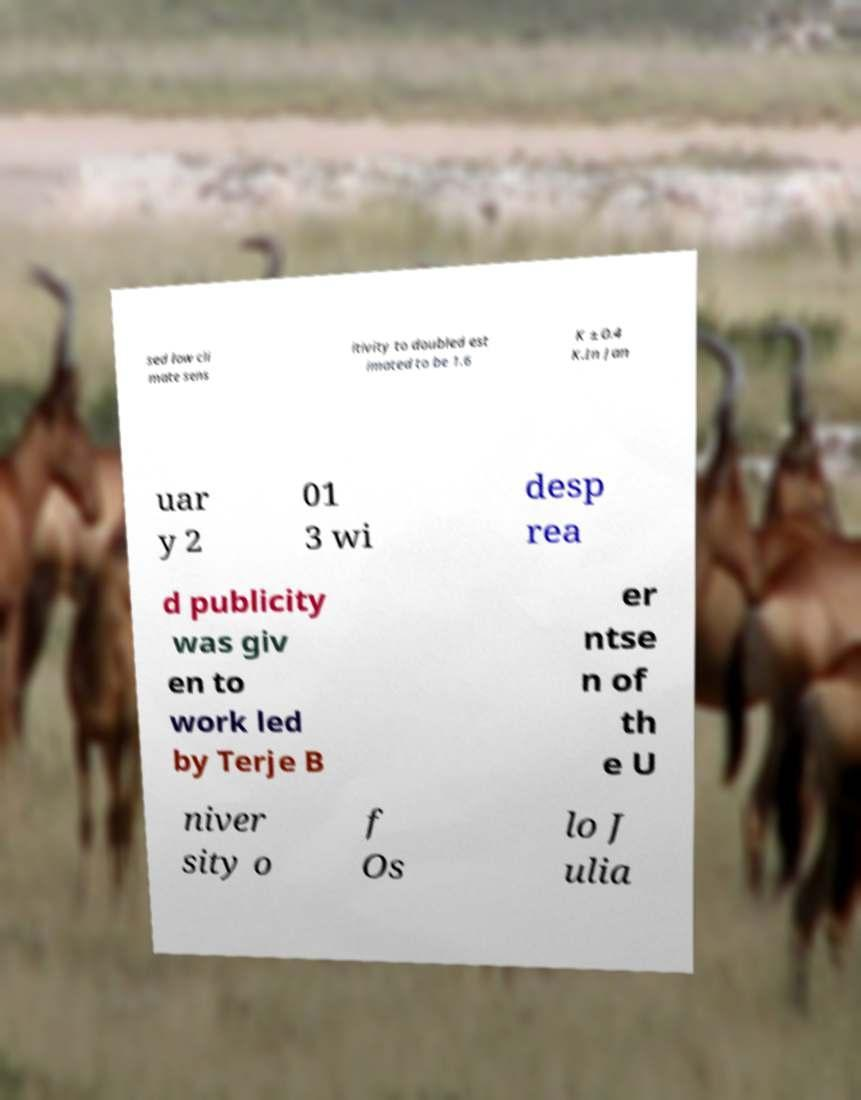Could you assist in decoding the text presented in this image and type it out clearly? sed low cli mate sens itivity to doubled est imated to be 1.6 K ± 0.4 K.In Jan uar y 2 01 3 wi desp rea d publicity was giv en to work led by Terje B er ntse n of th e U niver sity o f Os lo J ulia 